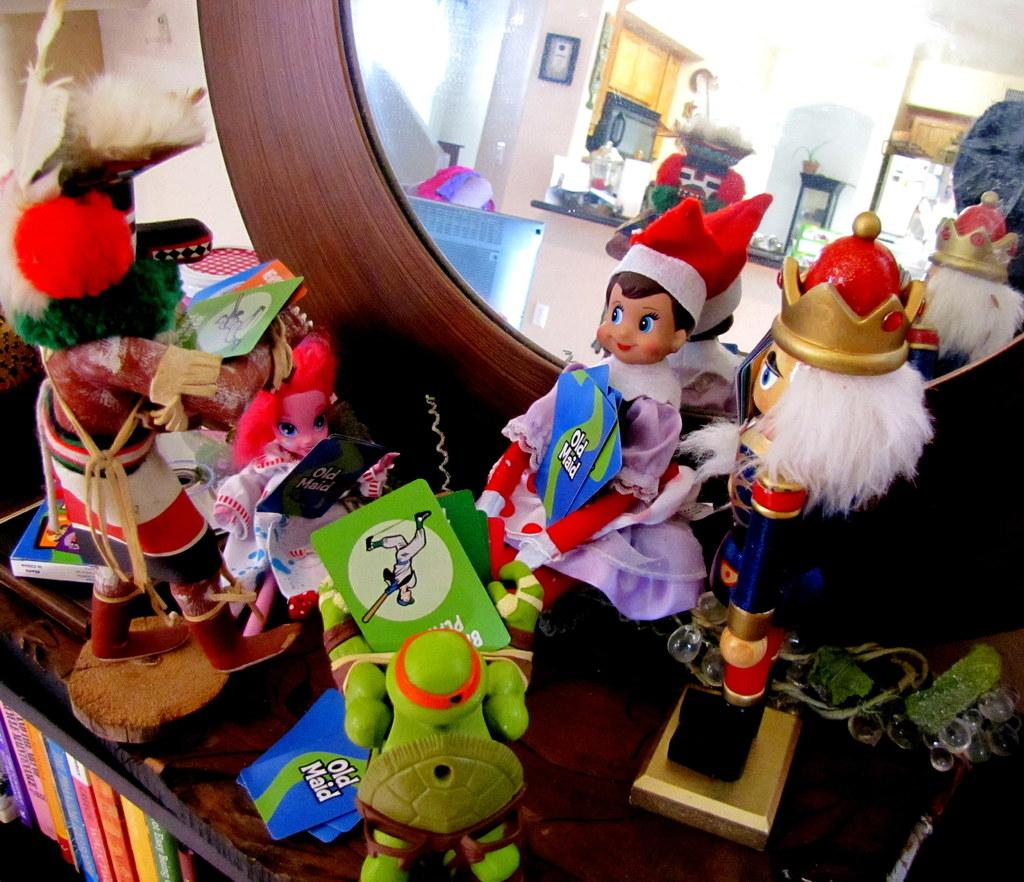What is the main object in the image? There is a mirror stand in the image. What is placed on the mirror stand? Toys are placed on the mirror stand. Are there any other objects visible in the image? Yes, there are books visible in the image. What type of treatment is being administered to the guitar in the image? There is no guitar present in the image, so no treatment is being administered. 